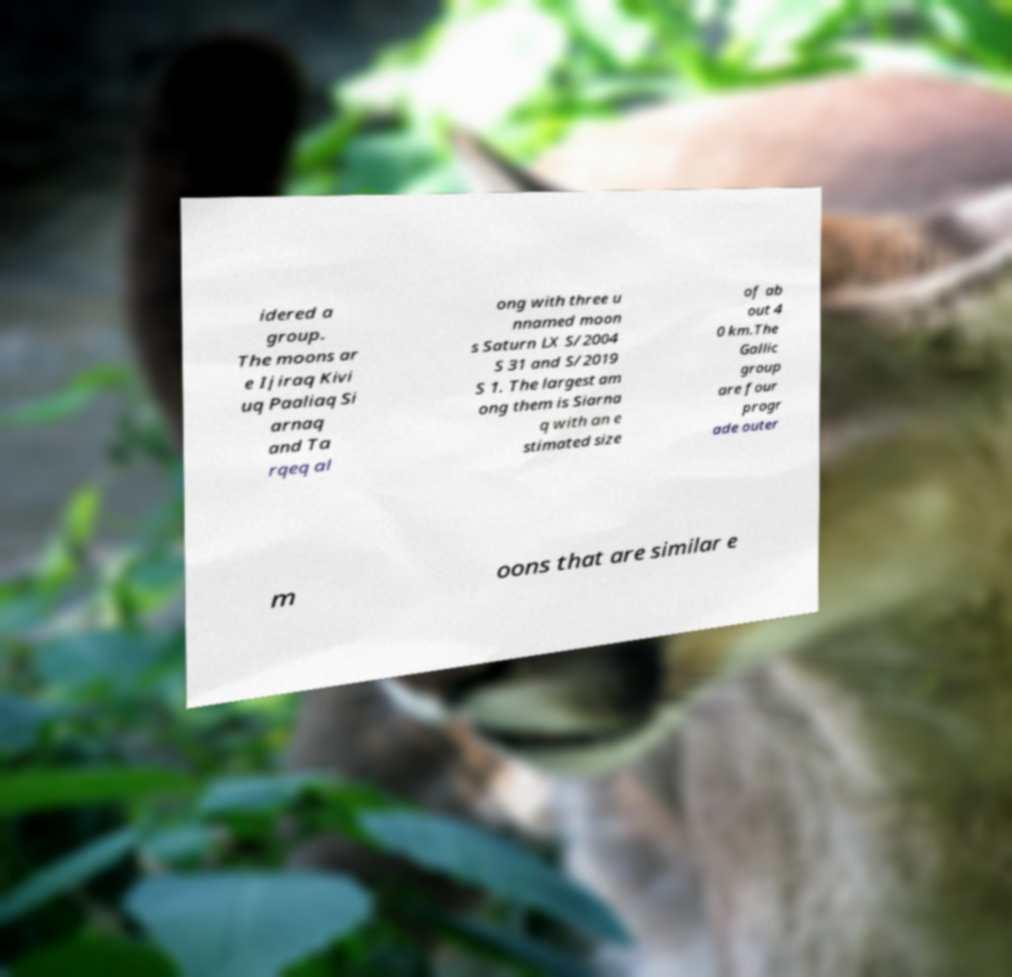Could you assist in decoding the text presented in this image and type it out clearly? idered a group. The moons ar e Ijiraq Kivi uq Paaliaq Si arnaq and Ta rqeq al ong with three u nnamed moon s Saturn LX S/2004 S 31 and S/2019 S 1. The largest am ong them is Siarna q with an e stimated size of ab out 4 0 km.The Gallic group are four progr ade outer m oons that are similar e 